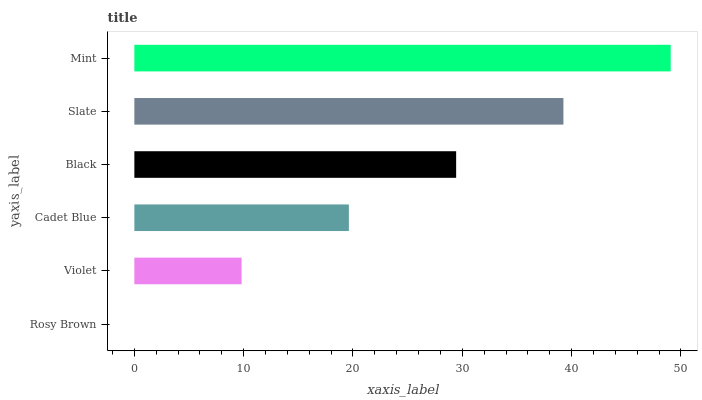Is Rosy Brown the minimum?
Answer yes or no. Yes. Is Mint the maximum?
Answer yes or no. Yes. Is Violet the minimum?
Answer yes or no. No. Is Violet the maximum?
Answer yes or no. No. Is Violet greater than Rosy Brown?
Answer yes or no. Yes. Is Rosy Brown less than Violet?
Answer yes or no. Yes. Is Rosy Brown greater than Violet?
Answer yes or no. No. Is Violet less than Rosy Brown?
Answer yes or no. No. Is Black the high median?
Answer yes or no. Yes. Is Cadet Blue the low median?
Answer yes or no. Yes. Is Mint the high median?
Answer yes or no. No. Is Rosy Brown the low median?
Answer yes or no. No. 